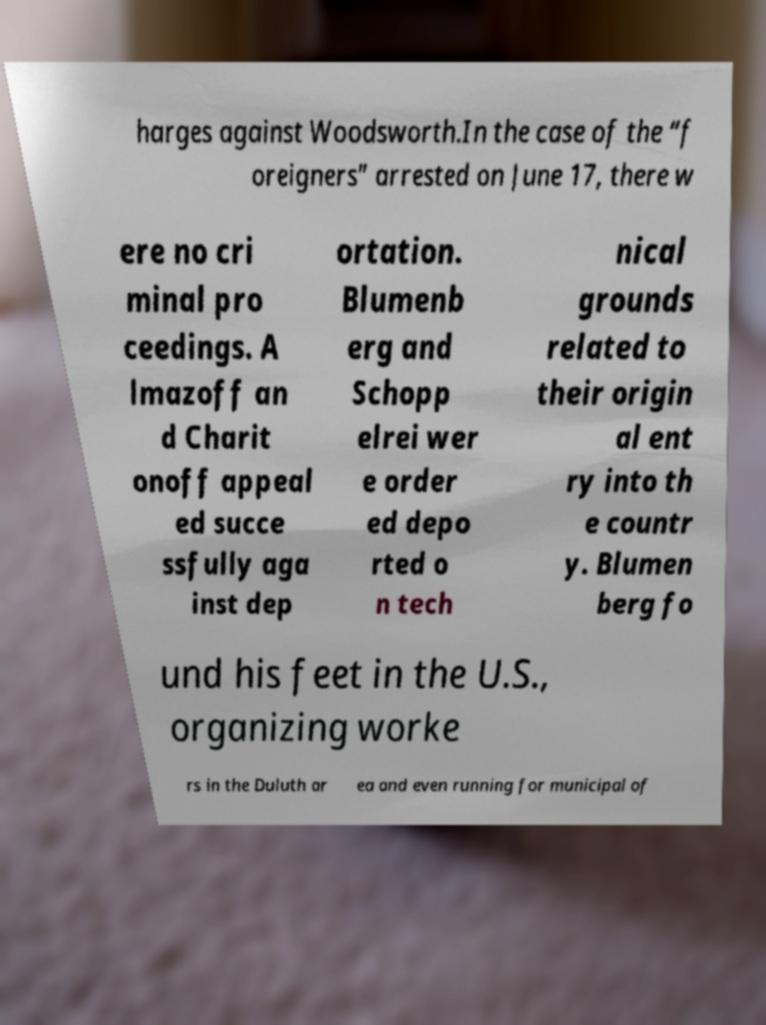For documentation purposes, I need the text within this image transcribed. Could you provide that? harges against Woodsworth.In the case of the “f oreigners” arrested on June 17, there w ere no cri minal pro ceedings. A lmazoff an d Charit onoff appeal ed succe ssfully aga inst dep ortation. Blumenb erg and Schopp elrei wer e order ed depo rted o n tech nical grounds related to their origin al ent ry into th e countr y. Blumen berg fo und his feet in the U.S., organizing worke rs in the Duluth ar ea and even running for municipal of 